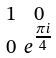<formula> <loc_0><loc_0><loc_500><loc_500>\begin{smallmatrix} 1 & 0 \\ 0 & e ^ { \frac { \pi i } { 4 } } \end{smallmatrix}</formula> 